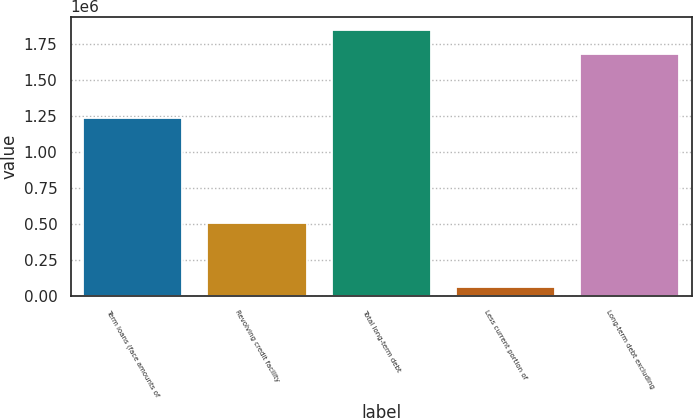Convert chart to OTSL. <chart><loc_0><loc_0><loc_500><loc_500><bar_chart><fcel>Term loans (face amounts of<fcel>Revolving credit facility<fcel>Total long-term debt<fcel>Less current portion of<fcel>Long-term debt excluding<nl><fcel>1.23194e+06<fcel>508125<fcel>1.84611e+06<fcel>61784<fcel>1.67828e+06<nl></chart> 